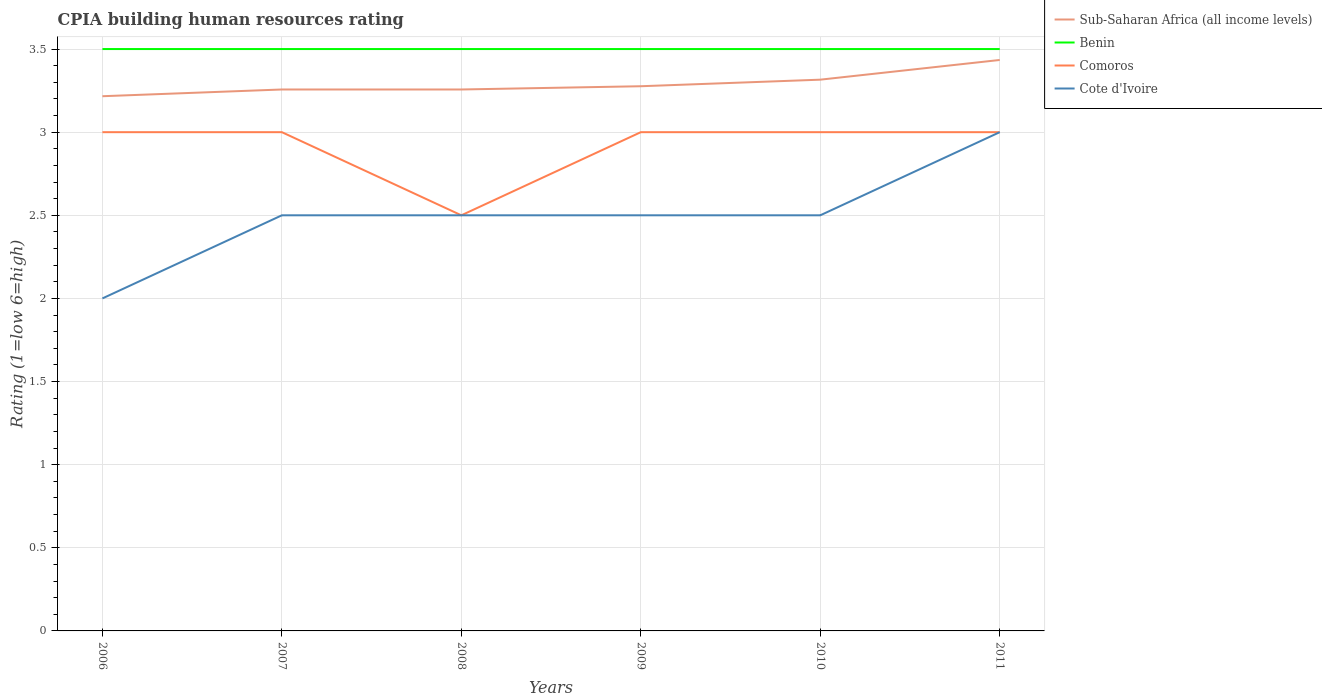How many different coloured lines are there?
Give a very brief answer. 4. Does the line corresponding to Cote d'Ivoire intersect with the line corresponding to Benin?
Your answer should be very brief. No. Is the number of lines equal to the number of legend labels?
Provide a short and direct response. Yes. Across all years, what is the maximum CPIA rating in Comoros?
Make the answer very short. 2.5. What is the total CPIA rating in Sub-Saharan Africa (all income levels) in the graph?
Ensure brevity in your answer.  -0.12. What is the difference between the highest and the lowest CPIA rating in Comoros?
Offer a terse response. 5. Is the CPIA rating in Comoros strictly greater than the CPIA rating in Sub-Saharan Africa (all income levels) over the years?
Make the answer very short. Yes. How many lines are there?
Make the answer very short. 4. Are the values on the major ticks of Y-axis written in scientific E-notation?
Offer a very short reply. No. Does the graph contain grids?
Provide a succinct answer. Yes. Where does the legend appear in the graph?
Offer a terse response. Top right. How many legend labels are there?
Keep it short and to the point. 4. How are the legend labels stacked?
Provide a succinct answer. Vertical. What is the title of the graph?
Offer a terse response. CPIA building human resources rating. What is the label or title of the Y-axis?
Your response must be concise. Rating (1=low 6=high). What is the Rating (1=low 6=high) in Sub-Saharan Africa (all income levels) in 2006?
Your answer should be very brief. 3.22. What is the Rating (1=low 6=high) of Benin in 2006?
Your response must be concise. 3.5. What is the Rating (1=low 6=high) in Comoros in 2006?
Provide a short and direct response. 3. What is the Rating (1=low 6=high) in Cote d'Ivoire in 2006?
Give a very brief answer. 2. What is the Rating (1=low 6=high) of Sub-Saharan Africa (all income levels) in 2007?
Offer a very short reply. 3.26. What is the Rating (1=low 6=high) of Benin in 2007?
Your answer should be compact. 3.5. What is the Rating (1=low 6=high) in Sub-Saharan Africa (all income levels) in 2008?
Your response must be concise. 3.26. What is the Rating (1=low 6=high) of Benin in 2008?
Your response must be concise. 3.5. What is the Rating (1=low 6=high) of Comoros in 2008?
Offer a very short reply. 2.5. What is the Rating (1=low 6=high) in Cote d'Ivoire in 2008?
Make the answer very short. 2.5. What is the Rating (1=low 6=high) in Sub-Saharan Africa (all income levels) in 2009?
Offer a terse response. 3.28. What is the Rating (1=low 6=high) in Comoros in 2009?
Offer a terse response. 3. What is the Rating (1=low 6=high) of Sub-Saharan Africa (all income levels) in 2010?
Your answer should be very brief. 3.32. What is the Rating (1=low 6=high) of Comoros in 2010?
Make the answer very short. 3. What is the Rating (1=low 6=high) in Sub-Saharan Africa (all income levels) in 2011?
Ensure brevity in your answer.  3.43. What is the Rating (1=low 6=high) in Benin in 2011?
Keep it short and to the point. 3.5. What is the Rating (1=low 6=high) of Cote d'Ivoire in 2011?
Your answer should be very brief. 3. Across all years, what is the maximum Rating (1=low 6=high) in Sub-Saharan Africa (all income levels)?
Offer a terse response. 3.43. Across all years, what is the maximum Rating (1=low 6=high) in Cote d'Ivoire?
Your answer should be very brief. 3. Across all years, what is the minimum Rating (1=low 6=high) in Sub-Saharan Africa (all income levels)?
Offer a very short reply. 3.22. Across all years, what is the minimum Rating (1=low 6=high) in Benin?
Ensure brevity in your answer.  3.5. Across all years, what is the minimum Rating (1=low 6=high) in Comoros?
Provide a succinct answer. 2.5. Across all years, what is the minimum Rating (1=low 6=high) of Cote d'Ivoire?
Keep it short and to the point. 2. What is the total Rating (1=low 6=high) in Sub-Saharan Africa (all income levels) in the graph?
Make the answer very short. 19.76. What is the total Rating (1=low 6=high) in Cote d'Ivoire in the graph?
Ensure brevity in your answer.  15. What is the difference between the Rating (1=low 6=high) of Sub-Saharan Africa (all income levels) in 2006 and that in 2007?
Provide a succinct answer. -0.04. What is the difference between the Rating (1=low 6=high) in Benin in 2006 and that in 2007?
Make the answer very short. 0. What is the difference between the Rating (1=low 6=high) in Comoros in 2006 and that in 2007?
Make the answer very short. 0. What is the difference between the Rating (1=low 6=high) of Cote d'Ivoire in 2006 and that in 2007?
Provide a succinct answer. -0.5. What is the difference between the Rating (1=low 6=high) in Sub-Saharan Africa (all income levels) in 2006 and that in 2008?
Your answer should be compact. -0.04. What is the difference between the Rating (1=low 6=high) of Sub-Saharan Africa (all income levels) in 2006 and that in 2009?
Provide a succinct answer. -0.06. What is the difference between the Rating (1=low 6=high) of Comoros in 2006 and that in 2009?
Provide a short and direct response. 0. What is the difference between the Rating (1=low 6=high) in Sub-Saharan Africa (all income levels) in 2006 and that in 2010?
Your answer should be compact. -0.1. What is the difference between the Rating (1=low 6=high) of Benin in 2006 and that in 2010?
Your answer should be very brief. 0. What is the difference between the Rating (1=low 6=high) of Comoros in 2006 and that in 2010?
Keep it short and to the point. 0. What is the difference between the Rating (1=low 6=high) in Sub-Saharan Africa (all income levels) in 2006 and that in 2011?
Your response must be concise. -0.22. What is the difference between the Rating (1=low 6=high) of Benin in 2006 and that in 2011?
Make the answer very short. 0. What is the difference between the Rating (1=low 6=high) of Comoros in 2007 and that in 2008?
Your answer should be very brief. 0.5. What is the difference between the Rating (1=low 6=high) of Cote d'Ivoire in 2007 and that in 2008?
Keep it short and to the point. 0. What is the difference between the Rating (1=low 6=high) of Sub-Saharan Africa (all income levels) in 2007 and that in 2009?
Provide a succinct answer. -0.02. What is the difference between the Rating (1=low 6=high) of Sub-Saharan Africa (all income levels) in 2007 and that in 2010?
Your answer should be very brief. -0.06. What is the difference between the Rating (1=low 6=high) in Benin in 2007 and that in 2010?
Provide a short and direct response. 0. What is the difference between the Rating (1=low 6=high) of Sub-Saharan Africa (all income levels) in 2007 and that in 2011?
Offer a very short reply. -0.18. What is the difference between the Rating (1=low 6=high) in Comoros in 2007 and that in 2011?
Make the answer very short. 0. What is the difference between the Rating (1=low 6=high) in Sub-Saharan Africa (all income levels) in 2008 and that in 2009?
Provide a short and direct response. -0.02. What is the difference between the Rating (1=low 6=high) in Benin in 2008 and that in 2009?
Ensure brevity in your answer.  0. What is the difference between the Rating (1=low 6=high) of Comoros in 2008 and that in 2009?
Your answer should be very brief. -0.5. What is the difference between the Rating (1=low 6=high) in Cote d'Ivoire in 2008 and that in 2009?
Keep it short and to the point. 0. What is the difference between the Rating (1=low 6=high) in Sub-Saharan Africa (all income levels) in 2008 and that in 2010?
Give a very brief answer. -0.06. What is the difference between the Rating (1=low 6=high) of Benin in 2008 and that in 2010?
Give a very brief answer. 0. What is the difference between the Rating (1=low 6=high) in Sub-Saharan Africa (all income levels) in 2008 and that in 2011?
Keep it short and to the point. -0.18. What is the difference between the Rating (1=low 6=high) of Benin in 2008 and that in 2011?
Provide a succinct answer. 0. What is the difference between the Rating (1=low 6=high) in Cote d'Ivoire in 2008 and that in 2011?
Ensure brevity in your answer.  -0.5. What is the difference between the Rating (1=low 6=high) in Sub-Saharan Africa (all income levels) in 2009 and that in 2010?
Provide a short and direct response. -0.04. What is the difference between the Rating (1=low 6=high) in Benin in 2009 and that in 2010?
Offer a very short reply. 0. What is the difference between the Rating (1=low 6=high) of Sub-Saharan Africa (all income levels) in 2009 and that in 2011?
Your answer should be very brief. -0.16. What is the difference between the Rating (1=low 6=high) in Benin in 2009 and that in 2011?
Ensure brevity in your answer.  0. What is the difference between the Rating (1=low 6=high) in Sub-Saharan Africa (all income levels) in 2010 and that in 2011?
Offer a very short reply. -0.12. What is the difference between the Rating (1=low 6=high) in Benin in 2010 and that in 2011?
Your answer should be very brief. 0. What is the difference between the Rating (1=low 6=high) in Comoros in 2010 and that in 2011?
Provide a short and direct response. 0. What is the difference between the Rating (1=low 6=high) in Cote d'Ivoire in 2010 and that in 2011?
Provide a short and direct response. -0.5. What is the difference between the Rating (1=low 6=high) in Sub-Saharan Africa (all income levels) in 2006 and the Rating (1=low 6=high) in Benin in 2007?
Provide a succinct answer. -0.28. What is the difference between the Rating (1=low 6=high) of Sub-Saharan Africa (all income levels) in 2006 and the Rating (1=low 6=high) of Comoros in 2007?
Make the answer very short. 0.22. What is the difference between the Rating (1=low 6=high) of Sub-Saharan Africa (all income levels) in 2006 and the Rating (1=low 6=high) of Cote d'Ivoire in 2007?
Make the answer very short. 0.72. What is the difference between the Rating (1=low 6=high) in Comoros in 2006 and the Rating (1=low 6=high) in Cote d'Ivoire in 2007?
Ensure brevity in your answer.  0.5. What is the difference between the Rating (1=low 6=high) in Sub-Saharan Africa (all income levels) in 2006 and the Rating (1=low 6=high) in Benin in 2008?
Make the answer very short. -0.28. What is the difference between the Rating (1=low 6=high) of Sub-Saharan Africa (all income levels) in 2006 and the Rating (1=low 6=high) of Comoros in 2008?
Your answer should be very brief. 0.72. What is the difference between the Rating (1=low 6=high) in Sub-Saharan Africa (all income levels) in 2006 and the Rating (1=low 6=high) in Cote d'Ivoire in 2008?
Your answer should be compact. 0.72. What is the difference between the Rating (1=low 6=high) in Benin in 2006 and the Rating (1=low 6=high) in Cote d'Ivoire in 2008?
Your response must be concise. 1. What is the difference between the Rating (1=low 6=high) in Sub-Saharan Africa (all income levels) in 2006 and the Rating (1=low 6=high) in Benin in 2009?
Your answer should be very brief. -0.28. What is the difference between the Rating (1=low 6=high) in Sub-Saharan Africa (all income levels) in 2006 and the Rating (1=low 6=high) in Comoros in 2009?
Keep it short and to the point. 0.22. What is the difference between the Rating (1=low 6=high) in Sub-Saharan Africa (all income levels) in 2006 and the Rating (1=low 6=high) in Cote d'Ivoire in 2009?
Your answer should be compact. 0.72. What is the difference between the Rating (1=low 6=high) in Benin in 2006 and the Rating (1=low 6=high) in Comoros in 2009?
Your answer should be very brief. 0.5. What is the difference between the Rating (1=low 6=high) of Comoros in 2006 and the Rating (1=low 6=high) of Cote d'Ivoire in 2009?
Your answer should be compact. 0.5. What is the difference between the Rating (1=low 6=high) in Sub-Saharan Africa (all income levels) in 2006 and the Rating (1=low 6=high) in Benin in 2010?
Offer a terse response. -0.28. What is the difference between the Rating (1=low 6=high) in Sub-Saharan Africa (all income levels) in 2006 and the Rating (1=low 6=high) in Comoros in 2010?
Your answer should be very brief. 0.22. What is the difference between the Rating (1=low 6=high) of Sub-Saharan Africa (all income levels) in 2006 and the Rating (1=low 6=high) of Cote d'Ivoire in 2010?
Give a very brief answer. 0.72. What is the difference between the Rating (1=low 6=high) in Benin in 2006 and the Rating (1=low 6=high) in Comoros in 2010?
Make the answer very short. 0.5. What is the difference between the Rating (1=low 6=high) in Benin in 2006 and the Rating (1=low 6=high) in Cote d'Ivoire in 2010?
Ensure brevity in your answer.  1. What is the difference between the Rating (1=low 6=high) of Sub-Saharan Africa (all income levels) in 2006 and the Rating (1=low 6=high) of Benin in 2011?
Give a very brief answer. -0.28. What is the difference between the Rating (1=low 6=high) in Sub-Saharan Africa (all income levels) in 2006 and the Rating (1=low 6=high) in Comoros in 2011?
Make the answer very short. 0.22. What is the difference between the Rating (1=low 6=high) in Sub-Saharan Africa (all income levels) in 2006 and the Rating (1=low 6=high) in Cote d'Ivoire in 2011?
Make the answer very short. 0.22. What is the difference between the Rating (1=low 6=high) in Comoros in 2006 and the Rating (1=low 6=high) in Cote d'Ivoire in 2011?
Keep it short and to the point. 0. What is the difference between the Rating (1=low 6=high) of Sub-Saharan Africa (all income levels) in 2007 and the Rating (1=low 6=high) of Benin in 2008?
Your answer should be very brief. -0.24. What is the difference between the Rating (1=low 6=high) in Sub-Saharan Africa (all income levels) in 2007 and the Rating (1=low 6=high) in Comoros in 2008?
Keep it short and to the point. 0.76. What is the difference between the Rating (1=low 6=high) of Sub-Saharan Africa (all income levels) in 2007 and the Rating (1=low 6=high) of Cote d'Ivoire in 2008?
Ensure brevity in your answer.  0.76. What is the difference between the Rating (1=low 6=high) of Comoros in 2007 and the Rating (1=low 6=high) of Cote d'Ivoire in 2008?
Your response must be concise. 0.5. What is the difference between the Rating (1=low 6=high) of Sub-Saharan Africa (all income levels) in 2007 and the Rating (1=low 6=high) of Benin in 2009?
Make the answer very short. -0.24. What is the difference between the Rating (1=low 6=high) in Sub-Saharan Africa (all income levels) in 2007 and the Rating (1=low 6=high) in Comoros in 2009?
Your answer should be compact. 0.26. What is the difference between the Rating (1=low 6=high) in Sub-Saharan Africa (all income levels) in 2007 and the Rating (1=low 6=high) in Cote d'Ivoire in 2009?
Provide a short and direct response. 0.76. What is the difference between the Rating (1=low 6=high) of Sub-Saharan Africa (all income levels) in 2007 and the Rating (1=low 6=high) of Benin in 2010?
Give a very brief answer. -0.24. What is the difference between the Rating (1=low 6=high) of Sub-Saharan Africa (all income levels) in 2007 and the Rating (1=low 6=high) of Comoros in 2010?
Offer a very short reply. 0.26. What is the difference between the Rating (1=low 6=high) of Sub-Saharan Africa (all income levels) in 2007 and the Rating (1=low 6=high) of Cote d'Ivoire in 2010?
Give a very brief answer. 0.76. What is the difference between the Rating (1=low 6=high) in Benin in 2007 and the Rating (1=low 6=high) in Cote d'Ivoire in 2010?
Offer a terse response. 1. What is the difference between the Rating (1=low 6=high) in Comoros in 2007 and the Rating (1=low 6=high) in Cote d'Ivoire in 2010?
Provide a succinct answer. 0.5. What is the difference between the Rating (1=low 6=high) of Sub-Saharan Africa (all income levels) in 2007 and the Rating (1=low 6=high) of Benin in 2011?
Make the answer very short. -0.24. What is the difference between the Rating (1=low 6=high) of Sub-Saharan Africa (all income levels) in 2007 and the Rating (1=low 6=high) of Comoros in 2011?
Your answer should be very brief. 0.26. What is the difference between the Rating (1=low 6=high) of Sub-Saharan Africa (all income levels) in 2007 and the Rating (1=low 6=high) of Cote d'Ivoire in 2011?
Keep it short and to the point. 0.26. What is the difference between the Rating (1=low 6=high) of Benin in 2007 and the Rating (1=low 6=high) of Comoros in 2011?
Keep it short and to the point. 0.5. What is the difference between the Rating (1=low 6=high) of Sub-Saharan Africa (all income levels) in 2008 and the Rating (1=low 6=high) of Benin in 2009?
Give a very brief answer. -0.24. What is the difference between the Rating (1=low 6=high) of Sub-Saharan Africa (all income levels) in 2008 and the Rating (1=low 6=high) of Comoros in 2009?
Your response must be concise. 0.26. What is the difference between the Rating (1=low 6=high) of Sub-Saharan Africa (all income levels) in 2008 and the Rating (1=low 6=high) of Cote d'Ivoire in 2009?
Your response must be concise. 0.76. What is the difference between the Rating (1=low 6=high) of Benin in 2008 and the Rating (1=low 6=high) of Comoros in 2009?
Ensure brevity in your answer.  0.5. What is the difference between the Rating (1=low 6=high) of Benin in 2008 and the Rating (1=low 6=high) of Cote d'Ivoire in 2009?
Offer a very short reply. 1. What is the difference between the Rating (1=low 6=high) in Sub-Saharan Africa (all income levels) in 2008 and the Rating (1=low 6=high) in Benin in 2010?
Offer a very short reply. -0.24. What is the difference between the Rating (1=low 6=high) of Sub-Saharan Africa (all income levels) in 2008 and the Rating (1=low 6=high) of Comoros in 2010?
Keep it short and to the point. 0.26. What is the difference between the Rating (1=low 6=high) of Sub-Saharan Africa (all income levels) in 2008 and the Rating (1=low 6=high) of Cote d'Ivoire in 2010?
Your answer should be very brief. 0.76. What is the difference between the Rating (1=low 6=high) in Sub-Saharan Africa (all income levels) in 2008 and the Rating (1=low 6=high) in Benin in 2011?
Give a very brief answer. -0.24. What is the difference between the Rating (1=low 6=high) of Sub-Saharan Africa (all income levels) in 2008 and the Rating (1=low 6=high) of Comoros in 2011?
Your response must be concise. 0.26. What is the difference between the Rating (1=low 6=high) of Sub-Saharan Africa (all income levels) in 2008 and the Rating (1=low 6=high) of Cote d'Ivoire in 2011?
Make the answer very short. 0.26. What is the difference between the Rating (1=low 6=high) of Sub-Saharan Africa (all income levels) in 2009 and the Rating (1=low 6=high) of Benin in 2010?
Your answer should be compact. -0.22. What is the difference between the Rating (1=low 6=high) of Sub-Saharan Africa (all income levels) in 2009 and the Rating (1=low 6=high) of Comoros in 2010?
Make the answer very short. 0.28. What is the difference between the Rating (1=low 6=high) in Sub-Saharan Africa (all income levels) in 2009 and the Rating (1=low 6=high) in Cote d'Ivoire in 2010?
Offer a terse response. 0.78. What is the difference between the Rating (1=low 6=high) of Benin in 2009 and the Rating (1=low 6=high) of Comoros in 2010?
Provide a succinct answer. 0.5. What is the difference between the Rating (1=low 6=high) in Benin in 2009 and the Rating (1=low 6=high) in Cote d'Ivoire in 2010?
Ensure brevity in your answer.  1. What is the difference between the Rating (1=low 6=high) in Sub-Saharan Africa (all income levels) in 2009 and the Rating (1=low 6=high) in Benin in 2011?
Your answer should be very brief. -0.22. What is the difference between the Rating (1=low 6=high) in Sub-Saharan Africa (all income levels) in 2009 and the Rating (1=low 6=high) in Comoros in 2011?
Your response must be concise. 0.28. What is the difference between the Rating (1=low 6=high) of Sub-Saharan Africa (all income levels) in 2009 and the Rating (1=low 6=high) of Cote d'Ivoire in 2011?
Ensure brevity in your answer.  0.28. What is the difference between the Rating (1=low 6=high) in Sub-Saharan Africa (all income levels) in 2010 and the Rating (1=low 6=high) in Benin in 2011?
Your answer should be very brief. -0.18. What is the difference between the Rating (1=low 6=high) in Sub-Saharan Africa (all income levels) in 2010 and the Rating (1=low 6=high) in Comoros in 2011?
Give a very brief answer. 0.32. What is the difference between the Rating (1=low 6=high) of Sub-Saharan Africa (all income levels) in 2010 and the Rating (1=low 6=high) of Cote d'Ivoire in 2011?
Make the answer very short. 0.32. What is the difference between the Rating (1=low 6=high) in Benin in 2010 and the Rating (1=low 6=high) in Comoros in 2011?
Keep it short and to the point. 0.5. What is the difference between the Rating (1=low 6=high) of Comoros in 2010 and the Rating (1=low 6=high) of Cote d'Ivoire in 2011?
Offer a very short reply. 0. What is the average Rating (1=low 6=high) in Sub-Saharan Africa (all income levels) per year?
Give a very brief answer. 3.29. What is the average Rating (1=low 6=high) of Comoros per year?
Make the answer very short. 2.92. What is the average Rating (1=low 6=high) in Cote d'Ivoire per year?
Your response must be concise. 2.5. In the year 2006, what is the difference between the Rating (1=low 6=high) in Sub-Saharan Africa (all income levels) and Rating (1=low 6=high) in Benin?
Your response must be concise. -0.28. In the year 2006, what is the difference between the Rating (1=low 6=high) in Sub-Saharan Africa (all income levels) and Rating (1=low 6=high) in Comoros?
Your answer should be very brief. 0.22. In the year 2006, what is the difference between the Rating (1=low 6=high) of Sub-Saharan Africa (all income levels) and Rating (1=low 6=high) of Cote d'Ivoire?
Offer a very short reply. 1.22. In the year 2006, what is the difference between the Rating (1=low 6=high) of Benin and Rating (1=low 6=high) of Comoros?
Keep it short and to the point. 0.5. In the year 2006, what is the difference between the Rating (1=low 6=high) in Comoros and Rating (1=low 6=high) in Cote d'Ivoire?
Offer a very short reply. 1. In the year 2007, what is the difference between the Rating (1=low 6=high) of Sub-Saharan Africa (all income levels) and Rating (1=low 6=high) of Benin?
Your answer should be very brief. -0.24. In the year 2007, what is the difference between the Rating (1=low 6=high) in Sub-Saharan Africa (all income levels) and Rating (1=low 6=high) in Comoros?
Give a very brief answer. 0.26. In the year 2007, what is the difference between the Rating (1=low 6=high) in Sub-Saharan Africa (all income levels) and Rating (1=low 6=high) in Cote d'Ivoire?
Ensure brevity in your answer.  0.76. In the year 2008, what is the difference between the Rating (1=low 6=high) in Sub-Saharan Africa (all income levels) and Rating (1=low 6=high) in Benin?
Your answer should be very brief. -0.24. In the year 2008, what is the difference between the Rating (1=low 6=high) in Sub-Saharan Africa (all income levels) and Rating (1=low 6=high) in Comoros?
Make the answer very short. 0.76. In the year 2008, what is the difference between the Rating (1=low 6=high) of Sub-Saharan Africa (all income levels) and Rating (1=low 6=high) of Cote d'Ivoire?
Give a very brief answer. 0.76. In the year 2008, what is the difference between the Rating (1=low 6=high) in Benin and Rating (1=low 6=high) in Cote d'Ivoire?
Make the answer very short. 1. In the year 2009, what is the difference between the Rating (1=low 6=high) in Sub-Saharan Africa (all income levels) and Rating (1=low 6=high) in Benin?
Keep it short and to the point. -0.22. In the year 2009, what is the difference between the Rating (1=low 6=high) of Sub-Saharan Africa (all income levels) and Rating (1=low 6=high) of Comoros?
Make the answer very short. 0.28. In the year 2009, what is the difference between the Rating (1=low 6=high) of Sub-Saharan Africa (all income levels) and Rating (1=low 6=high) of Cote d'Ivoire?
Offer a terse response. 0.78. In the year 2009, what is the difference between the Rating (1=low 6=high) of Benin and Rating (1=low 6=high) of Comoros?
Ensure brevity in your answer.  0.5. In the year 2009, what is the difference between the Rating (1=low 6=high) in Comoros and Rating (1=low 6=high) in Cote d'Ivoire?
Your answer should be compact. 0.5. In the year 2010, what is the difference between the Rating (1=low 6=high) in Sub-Saharan Africa (all income levels) and Rating (1=low 6=high) in Benin?
Provide a short and direct response. -0.18. In the year 2010, what is the difference between the Rating (1=low 6=high) of Sub-Saharan Africa (all income levels) and Rating (1=low 6=high) of Comoros?
Your answer should be compact. 0.32. In the year 2010, what is the difference between the Rating (1=low 6=high) in Sub-Saharan Africa (all income levels) and Rating (1=low 6=high) in Cote d'Ivoire?
Your answer should be very brief. 0.82. In the year 2010, what is the difference between the Rating (1=low 6=high) in Benin and Rating (1=low 6=high) in Cote d'Ivoire?
Offer a terse response. 1. In the year 2010, what is the difference between the Rating (1=low 6=high) in Comoros and Rating (1=low 6=high) in Cote d'Ivoire?
Your response must be concise. 0.5. In the year 2011, what is the difference between the Rating (1=low 6=high) of Sub-Saharan Africa (all income levels) and Rating (1=low 6=high) of Benin?
Offer a very short reply. -0.07. In the year 2011, what is the difference between the Rating (1=low 6=high) in Sub-Saharan Africa (all income levels) and Rating (1=low 6=high) in Comoros?
Give a very brief answer. 0.43. In the year 2011, what is the difference between the Rating (1=low 6=high) of Sub-Saharan Africa (all income levels) and Rating (1=low 6=high) of Cote d'Ivoire?
Provide a short and direct response. 0.43. What is the ratio of the Rating (1=low 6=high) of Sub-Saharan Africa (all income levels) in 2006 to that in 2007?
Offer a very short reply. 0.99. What is the ratio of the Rating (1=low 6=high) of Cote d'Ivoire in 2006 to that in 2007?
Offer a terse response. 0.8. What is the ratio of the Rating (1=low 6=high) in Sub-Saharan Africa (all income levels) in 2006 to that in 2008?
Your answer should be very brief. 0.99. What is the ratio of the Rating (1=low 6=high) of Benin in 2006 to that in 2008?
Make the answer very short. 1. What is the ratio of the Rating (1=low 6=high) of Comoros in 2006 to that in 2008?
Your answer should be very brief. 1.2. What is the ratio of the Rating (1=low 6=high) of Sub-Saharan Africa (all income levels) in 2006 to that in 2009?
Your answer should be compact. 0.98. What is the ratio of the Rating (1=low 6=high) of Benin in 2006 to that in 2009?
Provide a succinct answer. 1. What is the ratio of the Rating (1=low 6=high) in Comoros in 2006 to that in 2009?
Ensure brevity in your answer.  1. What is the ratio of the Rating (1=low 6=high) of Cote d'Ivoire in 2006 to that in 2009?
Provide a succinct answer. 0.8. What is the ratio of the Rating (1=low 6=high) in Sub-Saharan Africa (all income levels) in 2006 to that in 2010?
Keep it short and to the point. 0.97. What is the ratio of the Rating (1=low 6=high) of Benin in 2006 to that in 2010?
Offer a terse response. 1. What is the ratio of the Rating (1=low 6=high) in Sub-Saharan Africa (all income levels) in 2006 to that in 2011?
Offer a very short reply. 0.94. What is the ratio of the Rating (1=low 6=high) in Benin in 2006 to that in 2011?
Your answer should be very brief. 1. What is the ratio of the Rating (1=low 6=high) of Comoros in 2006 to that in 2011?
Give a very brief answer. 1. What is the ratio of the Rating (1=low 6=high) in Cote d'Ivoire in 2006 to that in 2011?
Offer a very short reply. 0.67. What is the ratio of the Rating (1=low 6=high) in Sub-Saharan Africa (all income levels) in 2007 to that in 2008?
Give a very brief answer. 1. What is the ratio of the Rating (1=low 6=high) in Benin in 2007 to that in 2009?
Provide a succinct answer. 1. What is the ratio of the Rating (1=low 6=high) in Comoros in 2007 to that in 2009?
Ensure brevity in your answer.  1. What is the ratio of the Rating (1=low 6=high) of Sub-Saharan Africa (all income levels) in 2007 to that in 2010?
Offer a terse response. 0.98. What is the ratio of the Rating (1=low 6=high) in Cote d'Ivoire in 2007 to that in 2010?
Give a very brief answer. 1. What is the ratio of the Rating (1=low 6=high) in Sub-Saharan Africa (all income levels) in 2007 to that in 2011?
Offer a very short reply. 0.95. What is the ratio of the Rating (1=low 6=high) in Benin in 2007 to that in 2011?
Offer a very short reply. 1. What is the ratio of the Rating (1=low 6=high) in Cote d'Ivoire in 2007 to that in 2011?
Your answer should be compact. 0.83. What is the ratio of the Rating (1=low 6=high) in Sub-Saharan Africa (all income levels) in 2008 to that in 2009?
Provide a succinct answer. 0.99. What is the ratio of the Rating (1=low 6=high) of Cote d'Ivoire in 2008 to that in 2009?
Offer a terse response. 1. What is the ratio of the Rating (1=low 6=high) in Sub-Saharan Africa (all income levels) in 2008 to that in 2010?
Your answer should be very brief. 0.98. What is the ratio of the Rating (1=low 6=high) of Cote d'Ivoire in 2008 to that in 2010?
Offer a very short reply. 1. What is the ratio of the Rating (1=low 6=high) in Sub-Saharan Africa (all income levels) in 2008 to that in 2011?
Your answer should be very brief. 0.95. What is the ratio of the Rating (1=low 6=high) in Comoros in 2008 to that in 2011?
Your response must be concise. 0.83. What is the ratio of the Rating (1=low 6=high) in Cote d'Ivoire in 2008 to that in 2011?
Provide a short and direct response. 0.83. What is the ratio of the Rating (1=low 6=high) in Sub-Saharan Africa (all income levels) in 2009 to that in 2010?
Your answer should be compact. 0.99. What is the ratio of the Rating (1=low 6=high) of Comoros in 2009 to that in 2010?
Provide a succinct answer. 1. What is the ratio of the Rating (1=low 6=high) of Cote d'Ivoire in 2009 to that in 2010?
Ensure brevity in your answer.  1. What is the ratio of the Rating (1=low 6=high) of Sub-Saharan Africa (all income levels) in 2009 to that in 2011?
Make the answer very short. 0.95. What is the ratio of the Rating (1=low 6=high) of Comoros in 2009 to that in 2011?
Offer a terse response. 1. What is the ratio of the Rating (1=low 6=high) in Sub-Saharan Africa (all income levels) in 2010 to that in 2011?
Your answer should be compact. 0.97. What is the ratio of the Rating (1=low 6=high) of Benin in 2010 to that in 2011?
Your response must be concise. 1. What is the ratio of the Rating (1=low 6=high) of Comoros in 2010 to that in 2011?
Keep it short and to the point. 1. What is the ratio of the Rating (1=low 6=high) of Cote d'Ivoire in 2010 to that in 2011?
Your response must be concise. 0.83. What is the difference between the highest and the second highest Rating (1=low 6=high) of Sub-Saharan Africa (all income levels)?
Ensure brevity in your answer.  0.12. What is the difference between the highest and the lowest Rating (1=low 6=high) in Sub-Saharan Africa (all income levels)?
Make the answer very short. 0.22. What is the difference between the highest and the lowest Rating (1=low 6=high) in Comoros?
Your answer should be compact. 0.5. What is the difference between the highest and the lowest Rating (1=low 6=high) in Cote d'Ivoire?
Keep it short and to the point. 1. 